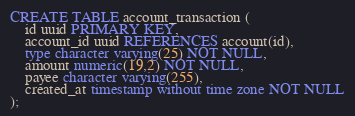Convert code to text. <code><loc_0><loc_0><loc_500><loc_500><_SQL_>CREATE TABLE account_transaction (
    id uuid PRIMARY KEY,
    account_id uuid REFERENCES account(id),
    type character varying(25) NOT NULL,
    amount numeric(19,2) NOT NULL,
    payee character varying(255),
    created_at timestamp without time zone NOT NULL
);
</code> 